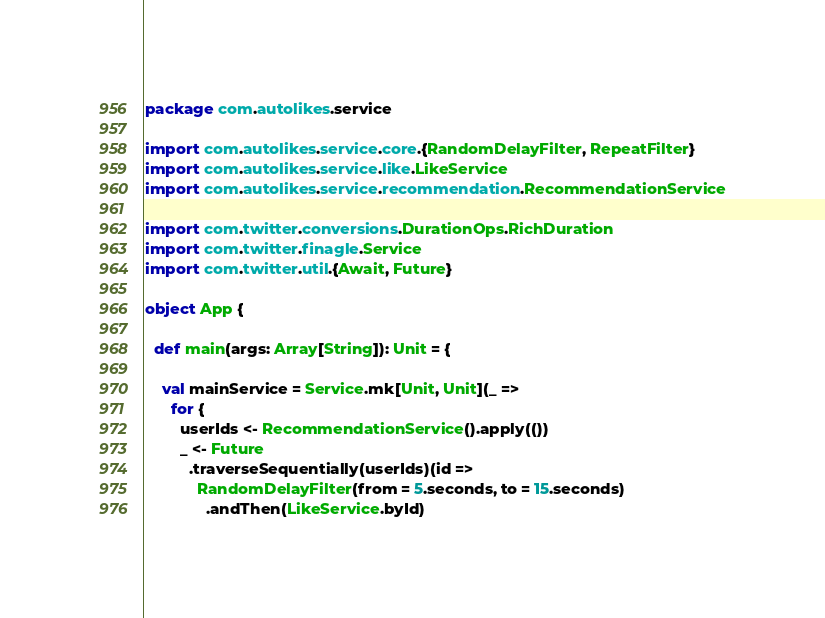Convert code to text. <code><loc_0><loc_0><loc_500><loc_500><_Scala_>package com.autolikes.service

import com.autolikes.service.core.{RandomDelayFilter, RepeatFilter}
import com.autolikes.service.like.LikeService
import com.autolikes.service.recommendation.RecommendationService

import com.twitter.conversions.DurationOps.RichDuration
import com.twitter.finagle.Service
import com.twitter.util.{Await, Future}

object App {

  def main(args: Array[String]): Unit = {

    val mainService = Service.mk[Unit, Unit](_ =>
      for {
        userIds <- RecommendationService().apply(())
        _ <- Future
          .traverseSequentially(userIds)(id =>
            RandomDelayFilter(from = 5.seconds, to = 15.seconds)
              .andThen(LikeService.byId)</code> 